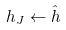<formula> <loc_0><loc_0><loc_500><loc_500>h _ { J } \leftarrow \hat { h }</formula> 